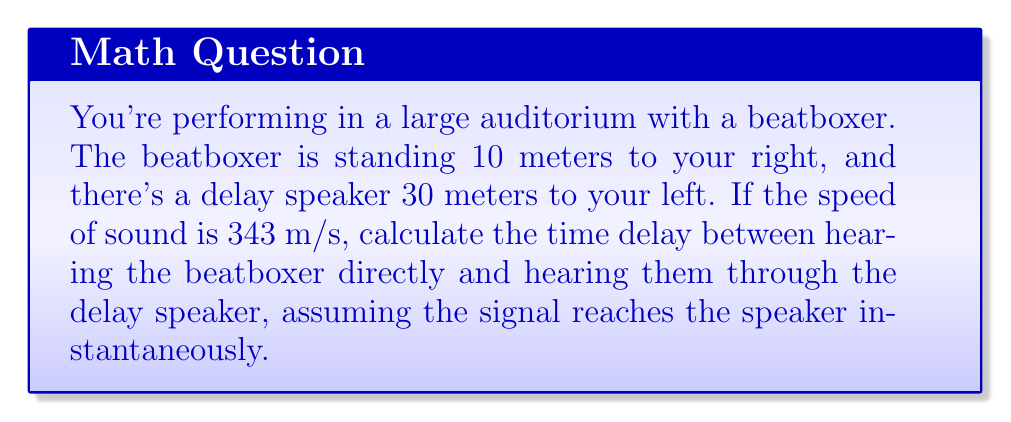Can you solve this math problem? To solve this problem, we need to calculate the difference in time it takes for the sound to reach you from two different sources:

1. Direct sound from the beatboxer:
   Distance = 10 m
   Time = Distance / Speed of sound
   $t_1 = \frac{10 \text{ m}}{343 \text{ m/s}} \approx 0.0292 \text{ s}$

2. Sound from the delay speaker:
   Distance = 30 m
   Time = Distance / Speed of sound
   $t_2 = \frac{30 \text{ m}}{343 \text{ m/s}} \approx 0.0875 \text{ s}$

3. Calculate the time delay:
   Delay = Time from speaker - Time from beatboxer
   $\Delta t = t_2 - t_1 = 0.0875 \text{ s} - 0.0292 \text{ s} = 0.0583 \text{ s}$

Therefore, the time delay between hearing the beatboxer directly and through the delay speaker is approximately 0.0583 seconds or 58.3 milliseconds.
Answer: 58.3 ms 